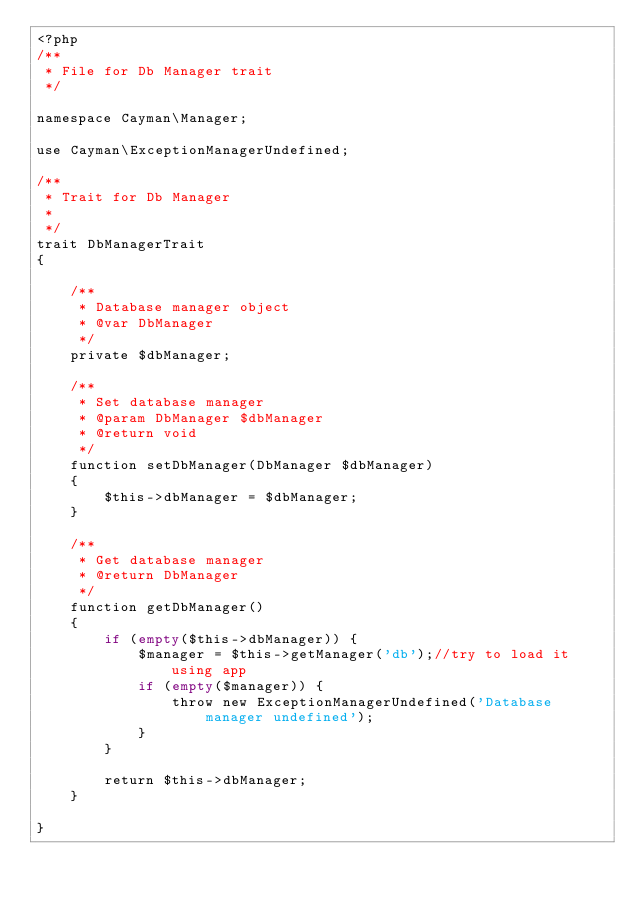Convert code to text. <code><loc_0><loc_0><loc_500><loc_500><_PHP_><?php
/**
 * File for Db Manager trait
 */

namespace Cayman\Manager;

use Cayman\ExceptionManagerUndefined;

/**
 * Trait for Db Manager
 *
 */
trait DbManagerTrait
{
    
    /**
     * Database manager object
     * @var DbManager
     */
    private $dbManager;
    
    /**
     * Set database manager
     * @param DbManager $dbManager
     * @return void
     */
    function setDbManager(DbManager $dbManager)
    {
        $this->dbManager = $dbManager;
    }
    
    /**
     * Get database manager
     * @return DbManager
     */
    function getDbManager()
    {
        if (empty($this->dbManager)) {
            $manager = $this->getManager('db');//try to load it using app
            if (empty($manager)) {
                throw new ExceptionManagerUndefined('Database manager undefined');
            }
        }
        
        return $this->dbManager;
    }
    
}
</code> 